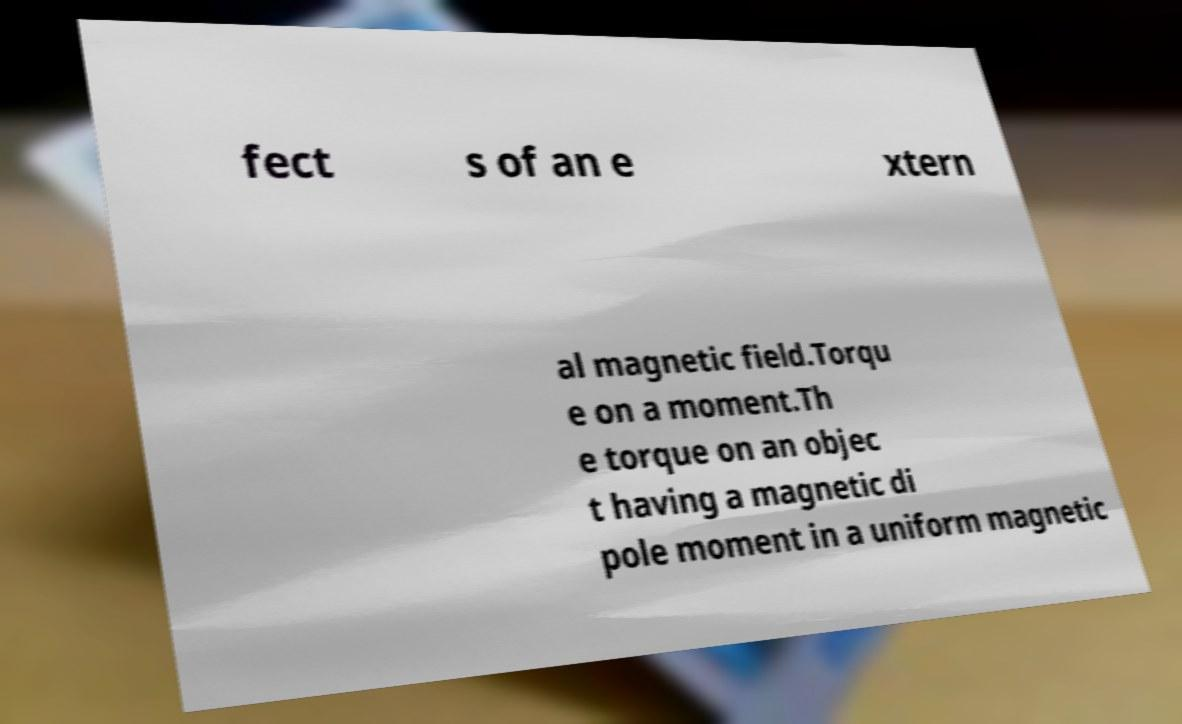I need the written content from this picture converted into text. Can you do that? fect s of an e xtern al magnetic field.Torqu e on a moment.Th e torque on an objec t having a magnetic di pole moment in a uniform magnetic 